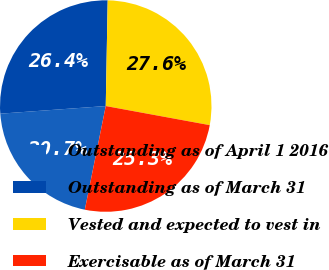Convert chart. <chart><loc_0><loc_0><loc_500><loc_500><pie_chart><fcel>Outstanding as of April 1 2016<fcel>Outstanding as of March 31<fcel>Vested and expected to vest in<fcel>Exercisable as of March 31<nl><fcel>20.68%<fcel>26.44%<fcel>27.6%<fcel>25.28%<nl></chart> 